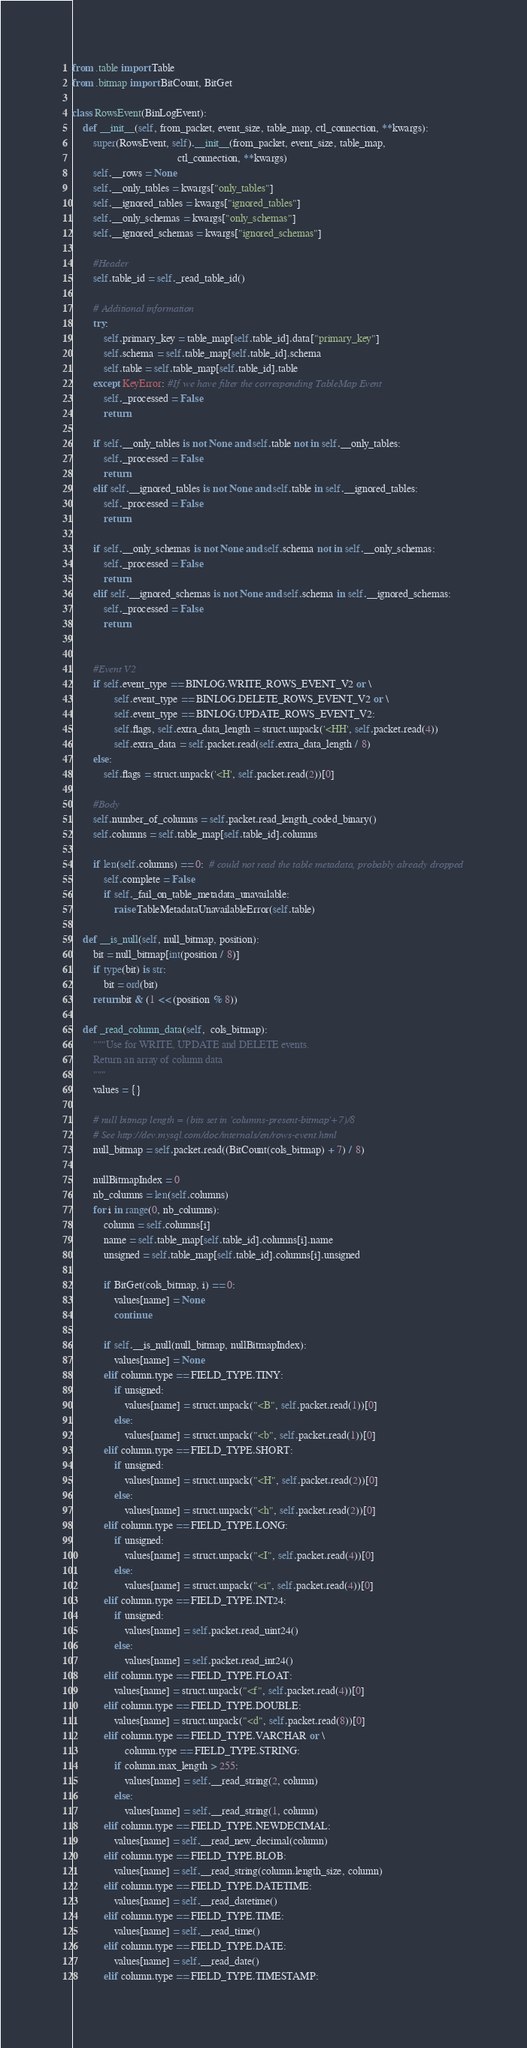<code> <loc_0><loc_0><loc_500><loc_500><_Python_>from .table import Table
from .bitmap import BitCount, BitGet

class RowsEvent(BinLogEvent):
    def __init__(self, from_packet, event_size, table_map, ctl_connection, **kwargs):
        super(RowsEvent, self).__init__(from_packet, event_size, table_map,
                                        ctl_connection, **kwargs)
        self.__rows = None
        self.__only_tables = kwargs["only_tables"]
        self.__ignored_tables = kwargs["ignored_tables"]
        self.__only_schemas = kwargs["only_schemas"]
        self.__ignored_schemas = kwargs["ignored_schemas"]

        #Header
        self.table_id = self._read_table_id()

        # Additional information
        try:
            self.primary_key = table_map[self.table_id].data["primary_key"]
            self.schema = self.table_map[self.table_id].schema
            self.table = self.table_map[self.table_id].table
        except KeyError: #If we have filter the corresponding TableMap Event
            self._processed = False
            return

        if self.__only_tables is not None and self.table not in self.__only_tables:
            self._processed = False
            return
        elif self.__ignored_tables is not None and self.table in self.__ignored_tables:
            self._processed = False
            return

        if self.__only_schemas is not None and self.schema not in self.__only_schemas:
            self._processed = False
            return
        elif self.__ignored_schemas is not None and self.schema in self.__ignored_schemas:
            self._processed = False
            return


        #Event V2
        if self.event_type == BINLOG.WRITE_ROWS_EVENT_V2 or \
                self.event_type == BINLOG.DELETE_ROWS_EVENT_V2 or \
                self.event_type == BINLOG.UPDATE_ROWS_EVENT_V2:
                self.flags, self.extra_data_length = struct.unpack('<HH', self.packet.read(4))
                self.extra_data = self.packet.read(self.extra_data_length / 8)
        else:
            self.flags = struct.unpack('<H', self.packet.read(2))[0]

        #Body
        self.number_of_columns = self.packet.read_length_coded_binary()
        self.columns = self.table_map[self.table_id].columns

        if len(self.columns) == 0:  # could not read the table metadata, probably already dropped
            self.complete = False
            if self._fail_on_table_metadata_unavailable:
                raise TableMetadataUnavailableError(self.table)

    def __is_null(self, null_bitmap, position):
        bit = null_bitmap[int(position / 8)]
        if type(bit) is str:
            bit = ord(bit)
        return bit & (1 << (position % 8))

    def _read_column_data(self,  cols_bitmap):
        """Use for WRITE, UPDATE and DELETE events.
        Return an array of column data
        """
        values = {}

        # null bitmap length = (bits set in 'columns-present-bitmap'+7)/8
        # See http://dev.mysql.com/doc/internals/en/rows-event.html
        null_bitmap = self.packet.read((BitCount(cols_bitmap) + 7) / 8)

        nullBitmapIndex = 0
        nb_columns = len(self.columns)
        for i in range(0, nb_columns):
            column = self.columns[i]
            name = self.table_map[self.table_id].columns[i].name
            unsigned = self.table_map[self.table_id].columns[i].unsigned

            if BitGet(cols_bitmap, i) == 0:
                values[name] = None
                continue

            if self.__is_null(null_bitmap, nullBitmapIndex):
                values[name] = None
            elif column.type == FIELD_TYPE.TINY:
                if unsigned:
                    values[name] = struct.unpack("<B", self.packet.read(1))[0]
                else:
                    values[name] = struct.unpack("<b", self.packet.read(1))[0]
            elif column.type == FIELD_TYPE.SHORT:
                if unsigned:
                    values[name] = struct.unpack("<H", self.packet.read(2))[0]
                else:
                    values[name] = struct.unpack("<h", self.packet.read(2))[0]
            elif column.type == FIELD_TYPE.LONG:
                if unsigned:
                    values[name] = struct.unpack("<I", self.packet.read(4))[0]
                else:
                    values[name] = struct.unpack("<i", self.packet.read(4))[0]
            elif column.type == FIELD_TYPE.INT24:
                if unsigned:
                    values[name] = self.packet.read_uint24()
                else:
                    values[name] = self.packet.read_int24()
            elif column.type == FIELD_TYPE.FLOAT:
                values[name] = struct.unpack("<f", self.packet.read(4))[0]
            elif column.type == FIELD_TYPE.DOUBLE:
                values[name] = struct.unpack("<d", self.packet.read(8))[0]
            elif column.type == FIELD_TYPE.VARCHAR or \
                    column.type == FIELD_TYPE.STRING:
                if column.max_length > 255:
                    values[name] = self.__read_string(2, column)
                else:
                    values[name] = self.__read_string(1, column)
            elif column.type == FIELD_TYPE.NEWDECIMAL:
                values[name] = self.__read_new_decimal(column)
            elif column.type == FIELD_TYPE.BLOB:
                values[name] = self.__read_string(column.length_size, column)
            elif column.type == FIELD_TYPE.DATETIME:
                values[name] = self.__read_datetime()
            elif column.type == FIELD_TYPE.TIME:
                values[name] = self.__read_time()
            elif column.type == FIELD_TYPE.DATE:
                values[name] = self.__read_date()
            elif column.type == FIELD_TYPE.TIMESTAMP:</code> 